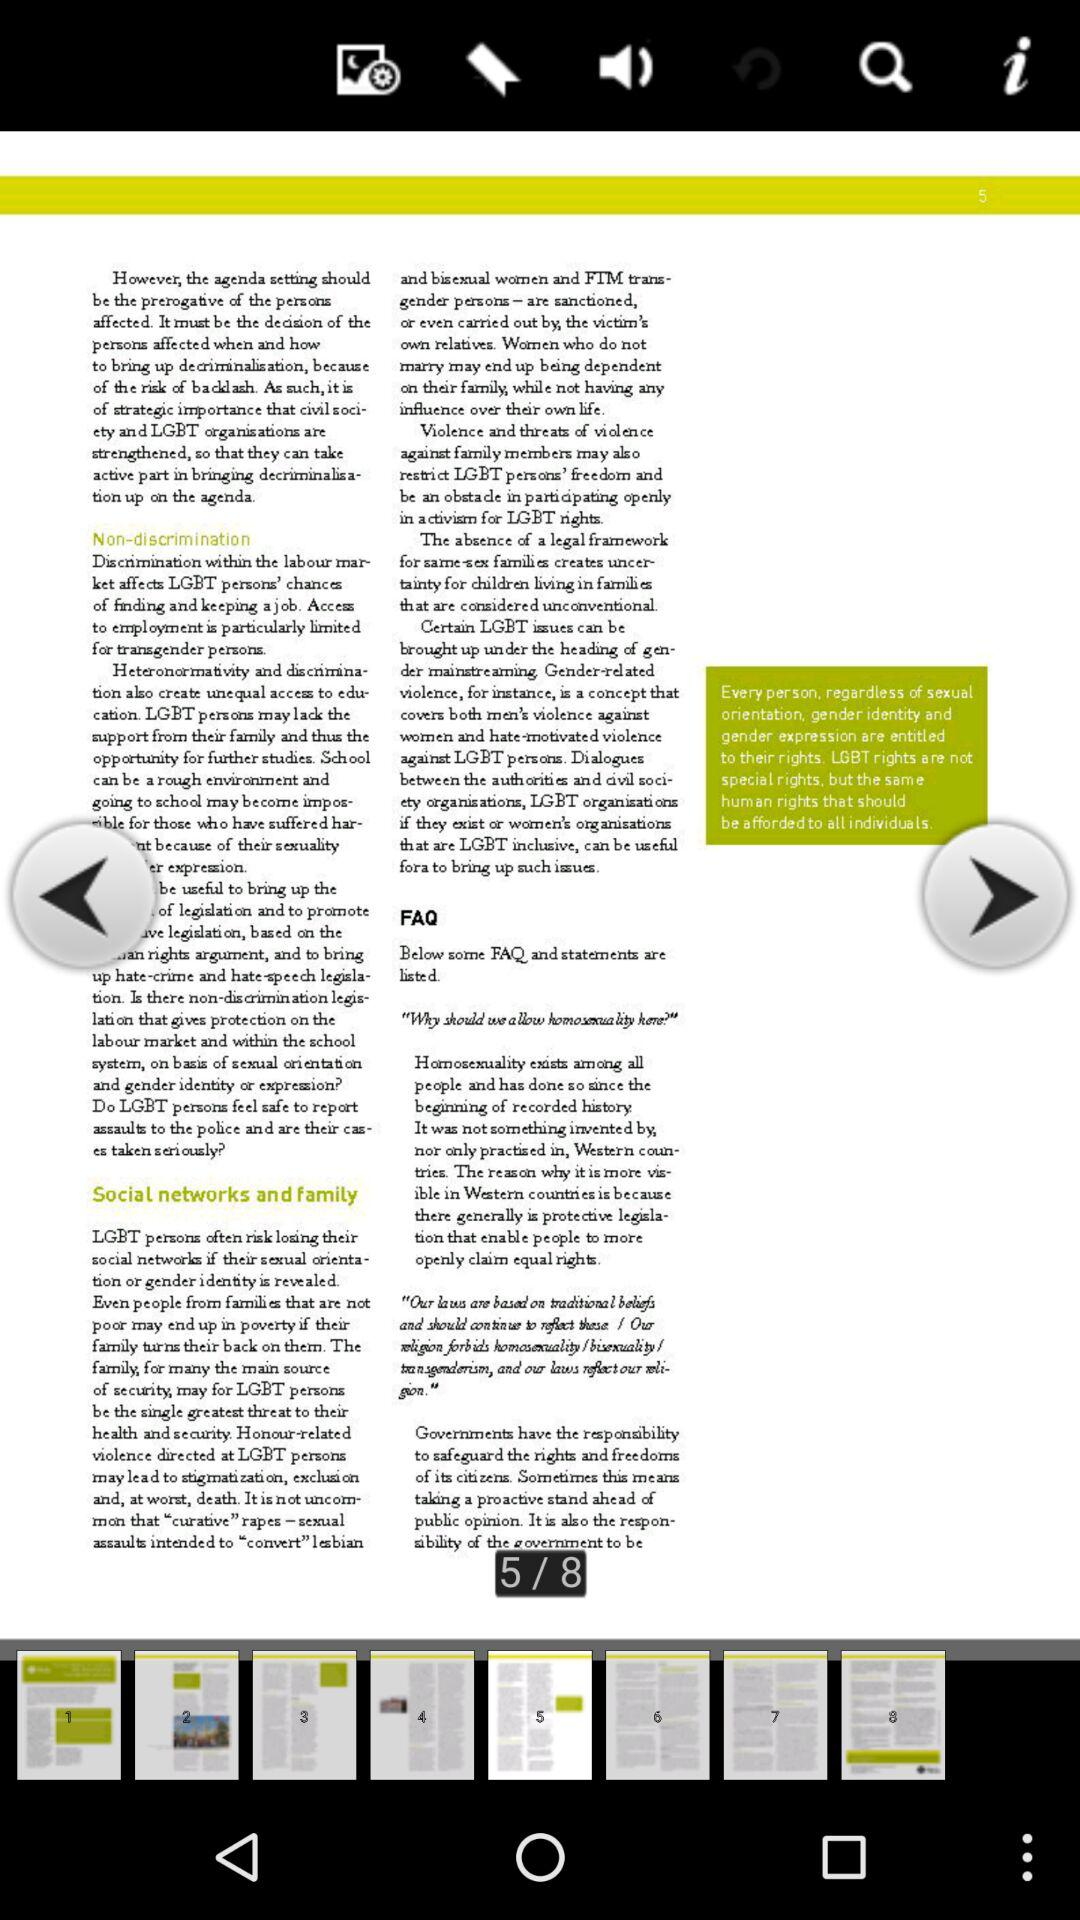Which page is the person currently on? The person is currently on the fifth page. 